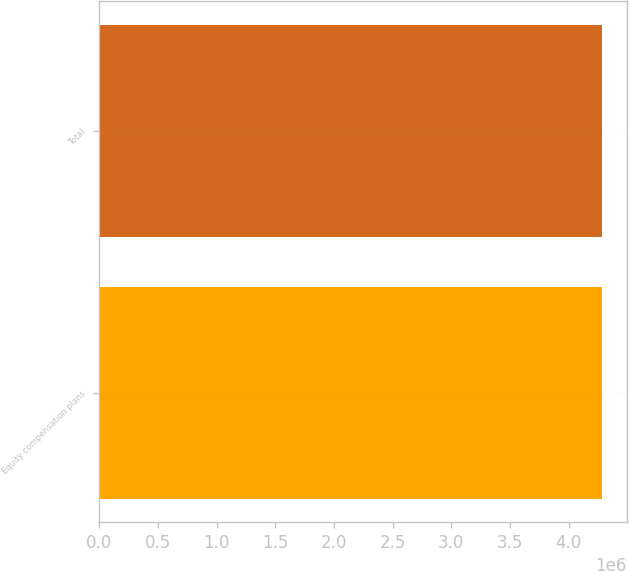Convert chart to OTSL. <chart><loc_0><loc_0><loc_500><loc_500><bar_chart><fcel>Equity compensation plans<fcel>Total<nl><fcel>4.28195e+06<fcel>4.28195e+06<nl></chart> 